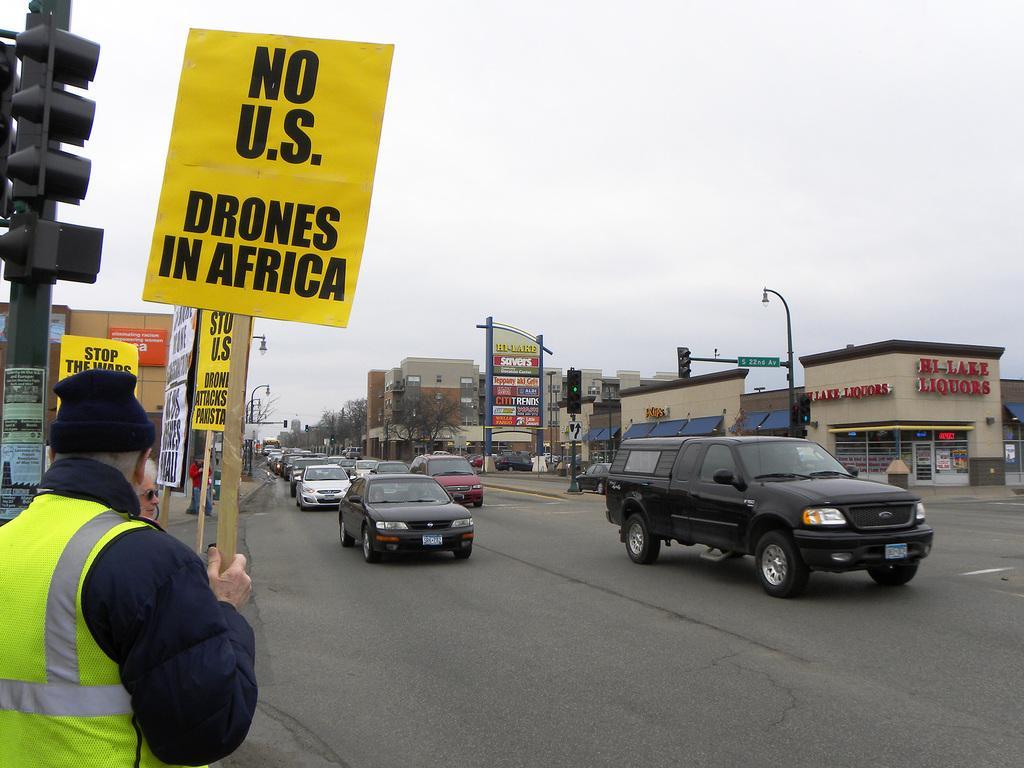How would you summarize this image in a sentence or two? In this image we can see group of vehicles parked on the road. In the left side of the image we can see some people holding boards with some text and some traffic lights. In the right side of the image we can see buildings with sign board, group of trees. At the top of the image we can see the sky. 